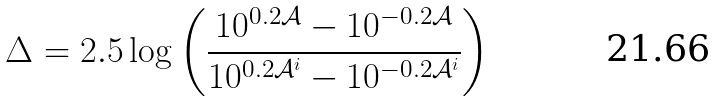<formula> <loc_0><loc_0><loc_500><loc_500>\Delta = 2 . 5 \log \left ( \frac { 1 0 ^ { 0 . 2 \mathcal { A } } - 1 0 ^ { - 0 . 2 \mathcal { A } } } { 1 0 ^ { 0 . 2 \mathcal { A } ^ { i } } - 1 0 ^ { - 0 . 2 \mathcal { A } ^ { i } } } \right )</formula> 